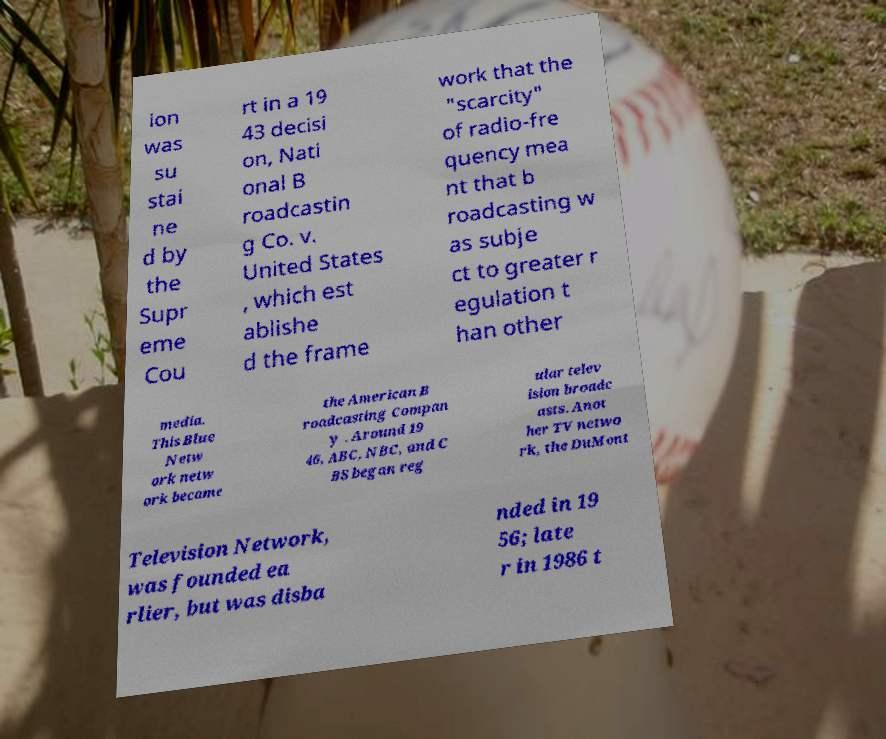Please read and relay the text visible in this image. What does it say? ion was su stai ne d by the Supr eme Cou rt in a 19 43 decisi on, Nati onal B roadcastin g Co. v. United States , which est ablishe d the frame work that the "scarcity" of radio-fre quency mea nt that b roadcasting w as subje ct to greater r egulation t han other media. This Blue Netw ork netw ork became the American B roadcasting Compan y . Around 19 46, ABC, NBC, and C BS began reg ular telev ision broadc asts. Anot her TV netwo rk, the DuMont Television Network, was founded ea rlier, but was disba nded in 19 56; late r in 1986 t 